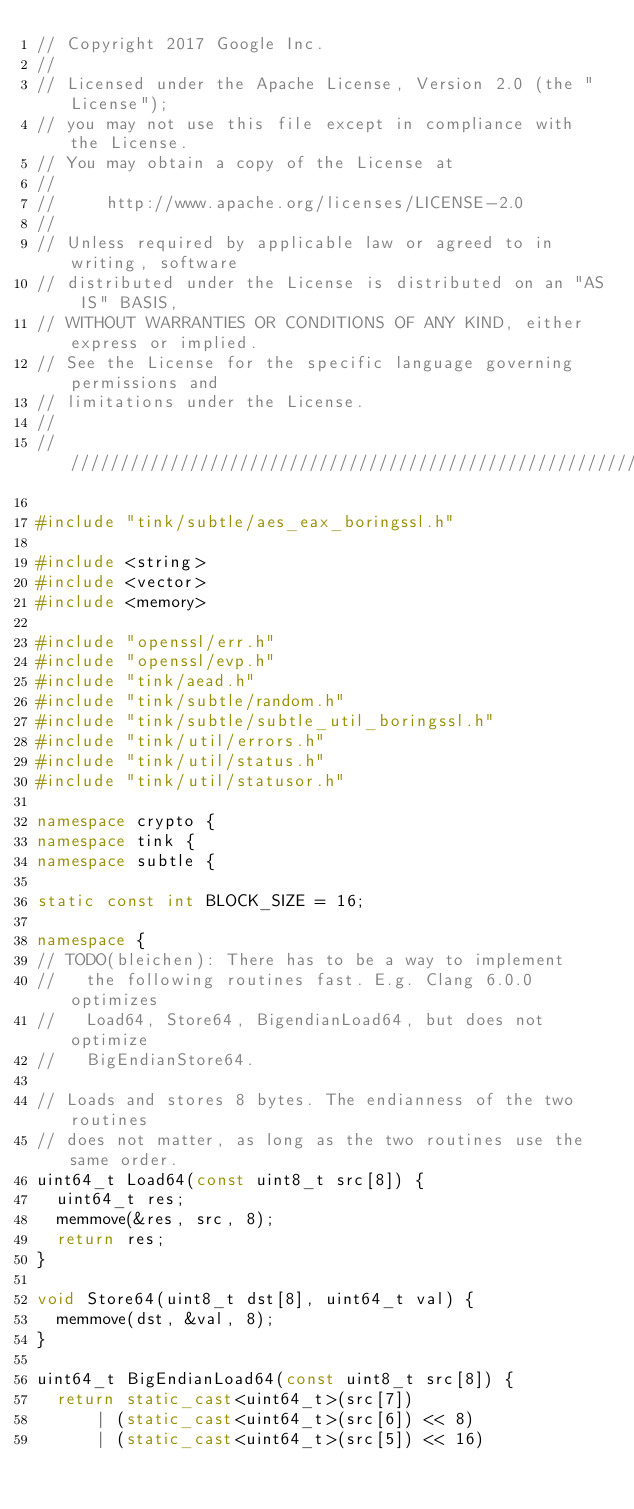<code> <loc_0><loc_0><loc_500><loc_500><_C++_>// Copyright 2017 Google Inc.
//
// Licensed under the Apache License, Version 2.0 (the "License");
// you may not use this file except in compliance with the License.
// You may obtain a copy of the License at
//
//     http://www.apache.org/licenses/LICENSE-2.0
//
// Unless required by applicable law or agreed to in writing, software
// distributed under the License is distributed on an "AS IS" BASIS,
// WITHOUT WARRANTIES OR CONDITIONS OF ANY KIND, either express or implied.
// See the License for the specific language governing permissions and
// limitations under the License.
//
///////////////////////////////////////////////////////////////////////////////

#include "tink/subtle/aes_eax_boringssl.h"

#include <string>
#include <vector>
#include <memory>

#include "openssl/err.h"
#include "openssl/evp.h"
#include "tink/aead.h"
#include "tink/subtle/random.h"
#include "tink/subtle/subtle_util_boringssl.h"
#include "tink/util/errors.h"
#include "tink/util/status.h"
#include "tink/util/statusor.h"

namespace crypto {
namespace tink {
namespace subtle {

static const int BLOCK_SIZE = 16;

namespace {
// TODO(bleichen): There has to be a way to implement
//   the following routines fast. E.g. Clang 6.0.0 optimizes
//   Load64, Store64, BigendianLoad64, but does not optimize
//   BigEndianStore64.

// Loads and stores 8 bytes. The endianness of the two routines
// does not matter, as long as the two routines use the same order.
uint64_t Load64(const uint8_t src[8]) {
  uint64_t res;
  memmove(&res, src, 8);
  return res;
}

void Store64(uint8_t dst[8], uint64_t val) {
  memmove(dst, &val, 8);
}

uint64_t BigEndianLoad64(const uint8_t src[8]) {
  return static_cast<uint64_t>(src[7])
      | (static_cast<uint64_t>(src[6]) << 8)
      | (static_cast<uint64_t>(src[5]) << 16)</code> 